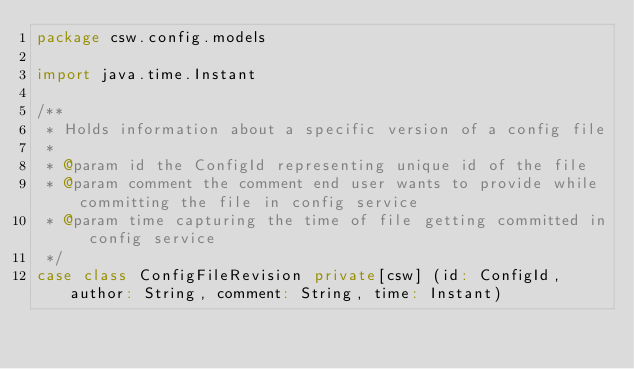<code> <loc_0><loc_0><loc_500><loc_500><_Scala_>package csw.config.models

import java.time.Instant

/**
 * Holds information about a specific version of a config file
 *
 * @param id the ConfigId representing unique id of the file
 * @param comment the comment end user wants to provide while committing the file in config service
 * @param time capturing the time of file getting committed in config service
 */
case class ConfigFileRevision private[csw] (id: ConfigId, author: String, comment: String, time: Instant)
</code> 